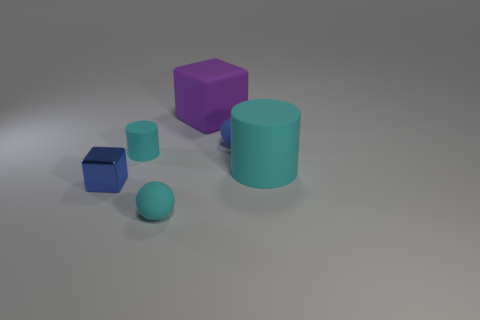Is there anything else that is the same material as the blue block?
Give a very brief answer. No. What number of big matte cylinders are to the left of the large object that is in front of the small blue matte sphere?
Offer a very short reply. 0. What number of cyan rubber objects are in front of the blue shiny cube?
Your answer should be compact. 1. How many other things are the same size as the cyan sphere?
Provide a short and direct response. 3. There is a blue thing that is the same shape as the purple object; what size is it?
Offer a terse response. Small. There is a matte thing that is on the right side of the blue ball; what shape is it?
Provide a short and direct response. Cylinder. What is the color of the cylinder on the right side of the small rubber cylinder that is left of the large purple cube?
Give a very brief answer. Cyan. What number of objects are tiny blue objects that are to the left of the large block or big blue cylinders?
Ensure brevity in your answer.  1. There is a cyan ball; does it have the same size as the matte cylinder that is on the left side of the large cyan thing?
Offer a very short reply. Yes. How many small objects are yellow rubber objects or blue blocks?
Your answer should be compact. 1. 